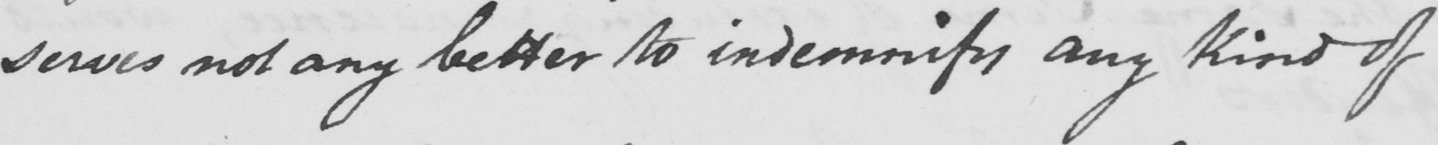Transcribe the text shown in this historical manuscript line. serves not any better to indemnity and kind of 